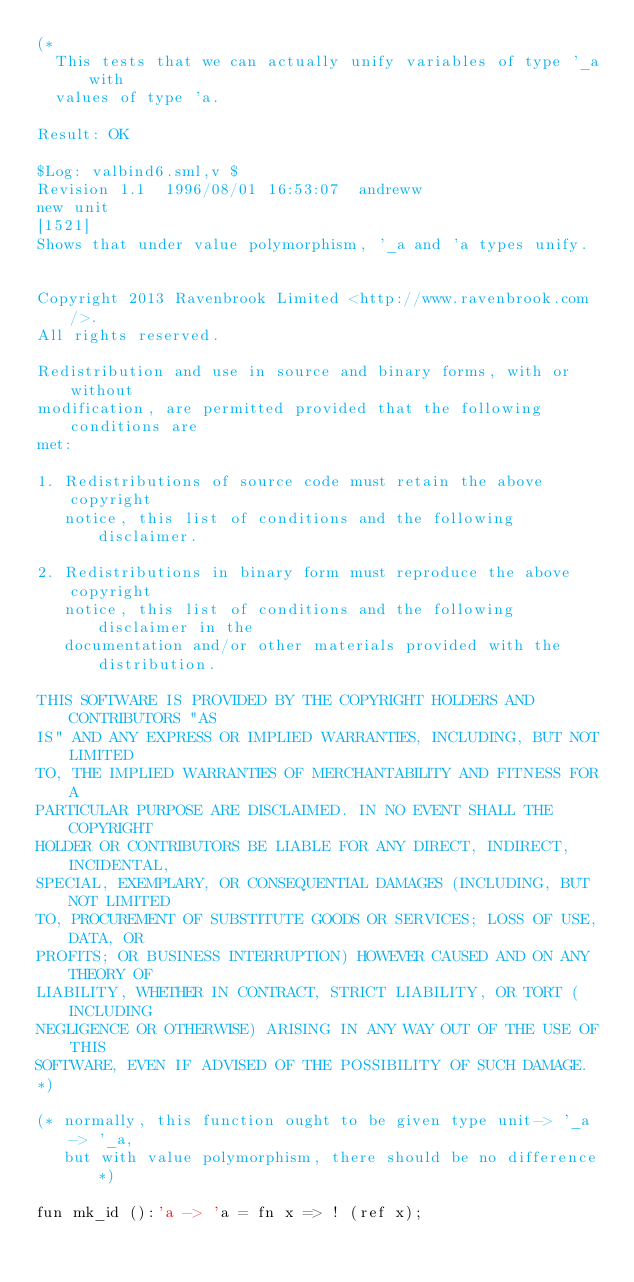Convert code to text. <code><loc_0><loc_0><loc_500><loc_500><_SML_>(*
  This tests that we can actually unify variables of type '_a with
  values of type 'a.

Result: OK

$Log: valbind6.sml,v $
Revision 1.1  1996/08/01 16:53:07  andreww
new unit
[1521]
Shows that under value polymorphism, '_a and 'a types unify.


Copyright 2013 Ravenbrook Limited <http://www.ravenbrook.com/>.
All rights reserved.

Redistribution and use in source and binary forms, with or without
modification, are permitted provided that the following conditions are
met:

1. Redistributions of source code must retain the above copyright
   notice, this list of conditions and the following disclaimer.

2. Redistributions in binary form must reproduce the above copyright
   notice, this list of conditions and the following disclaimer in the
   documentation and/or other materials provided with the distribution.

THIS SOFTWARE IS PROVIDED BY THE COPYRIGHT HOLDERS AND CONTRIBUTORS "AS
IS" AND ANY EXPRESS OR IMPLIED WARRANTIES, INCLUDING, BUT NOT LIMITED
TO, THE IMPLIED WARRANTIES OF MERCHANTABILITY AND FITNESS FOR A
PARTICULAR PURPOSE ARE DISCLAIMED. IN NO EVENT SHALL THE COPYRIGHT
HOLDER OR CONTRIBUTORS BE LIABLE FOR ANY DIRECT, INDIRECT, INCIDENTAL,
SPECIAL, EXEMPLARY, OR CONSEQUENTIAL DAMAGES (INCLUDING, BUT NOT LIMITED
TO, PROCUREMENT OF SUBSTITUTE GOODS OR SERVICES; LOSS OF USE, DATA, OR
PROFITS; OR BUSINESS INTERRUPTION) HOWEVER CAUSED AND ON ANY THEORY OF
LIABILITY, WHETHER IN CONTRACT, STRICT LIABILITY, OR TORT (INCLUDING
NEGLIGENCE OR OTHERWISE) ARISING IN ANY WAY OUT OF THE USE OF THIS
SOFTWARE, EVEN IF ADVISED OF THE POSSIBILITY OF SUCH DAMAGE.
*)

(* normally, this function ought to be given type unit-> '_a -> '_a,
   but with value polymorphism, there should be no difference *)

fun mk_id ():'a -> 'a = fn x => ! (ref x);


</code> 